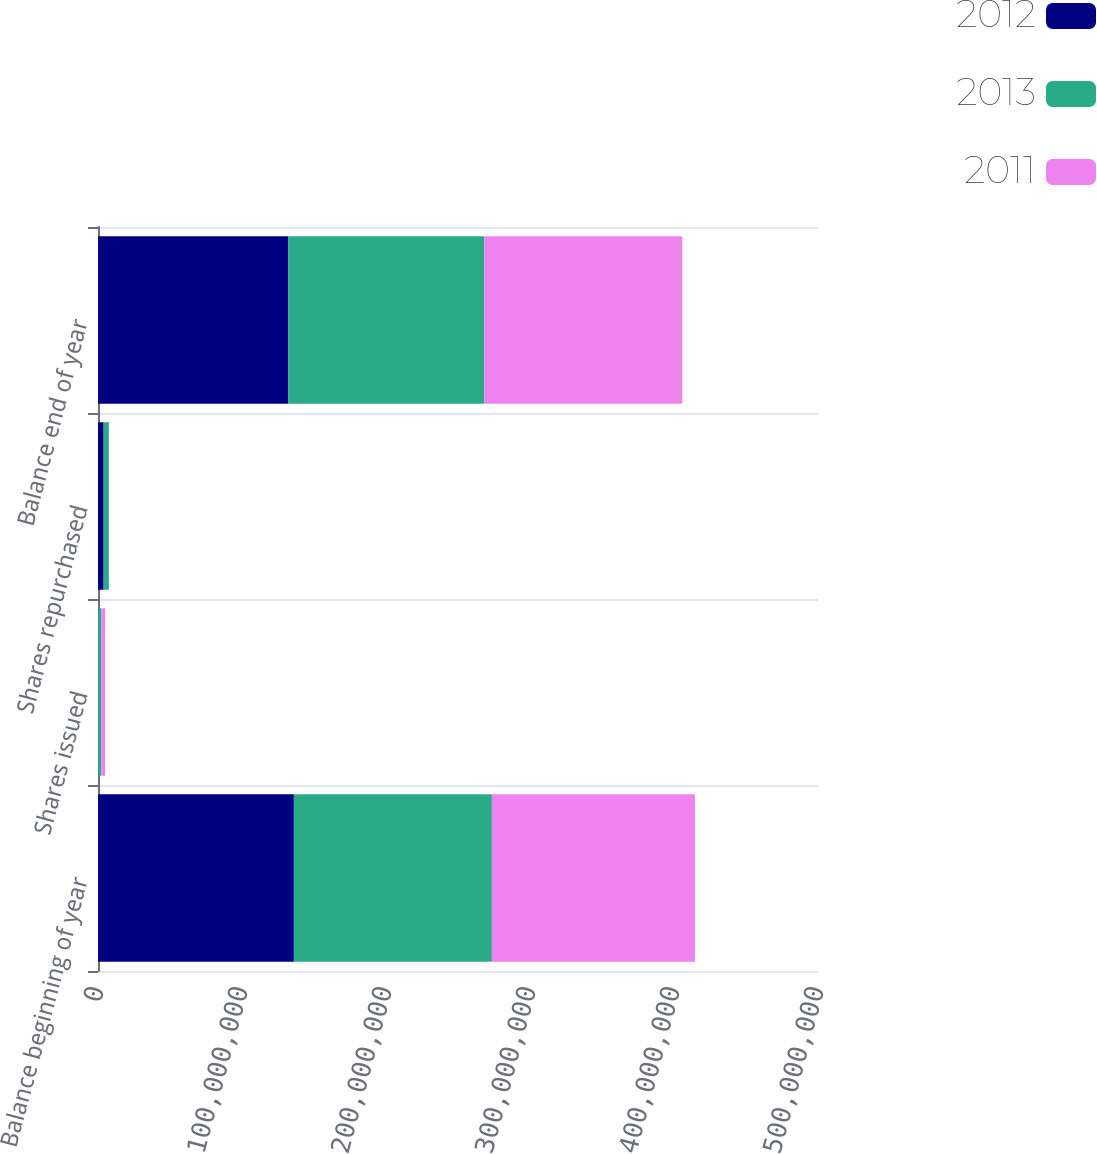<chart> <loc_0><loc_0><loc_500><loc_500><stacked_bar_chart><ecel><fcel>Balance beginning of year<fcel>Shares issued<fcel>Shares repurchased<fcel>Balance end of year<nl><fcel>2012<fcel>1.36018e+08<fcel>139790<fcel>3.92436e+06<fcel>1.32233e+08<nl><fcel>2013<fcel>1.3752e+08<fcel>2.11417e+06<fcel>3.61646e+06<fcel>1.36018e+08<nl><fcel>2011<fcel>1.4101e+08<fcel>2.7023e+06<fcel>6192.12<fcel>1.3752e+08<nl></chart> 